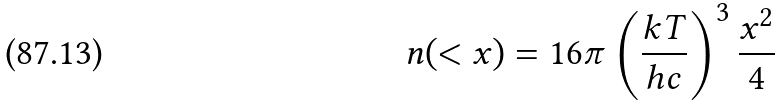<formula> <loc_0><loc_0><loc_500><loc_500>n ( < x ) = 1 6 \pi \left ( \frac { k T } { h c } \right ) ^ { 3 } \frac { x ^ { 2 } } { 4 }</formula> 